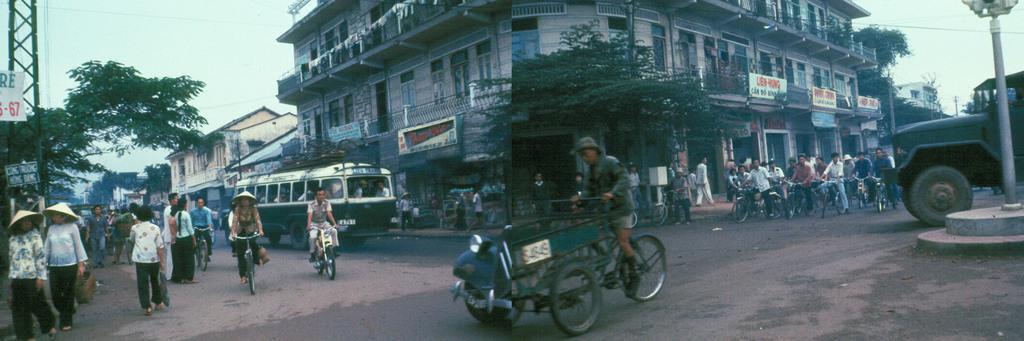Could you give a brief overview of what you see in this image? In this image I can see the road, few persons riding bicycles on the road, few vehicles and few persons on the road. I can see the sidewalk, few persons on the sidewalk, few poles, few trees, few buildings, few boards and the sky in the background. 